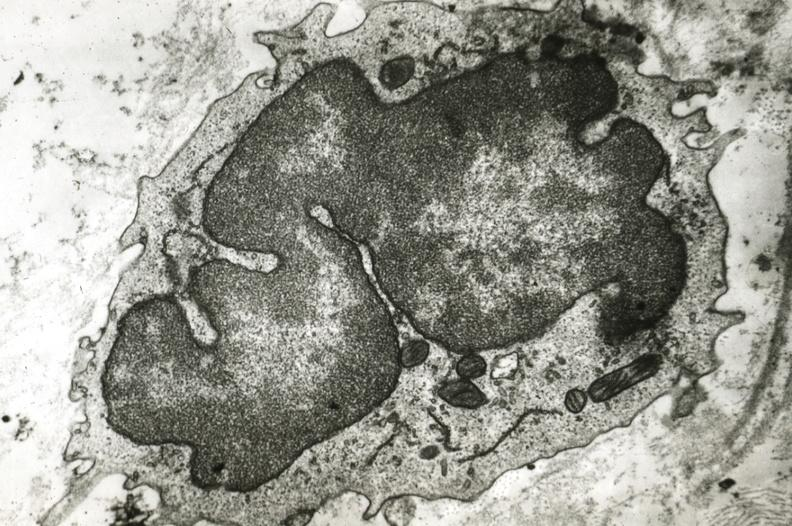s vasculature present?
Answer the question using a single word or phrase. Yes 